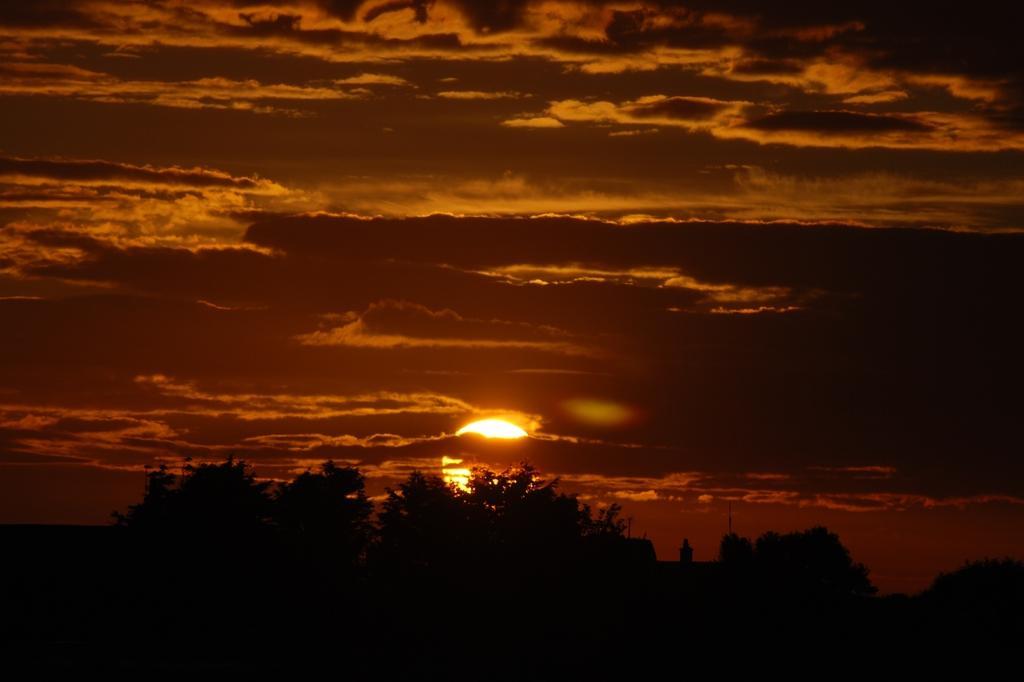How would you summarize this image in a sentence or two? In this image in the center there are trees and the sky is cloudy and in the background there is sun visible in the sky. 